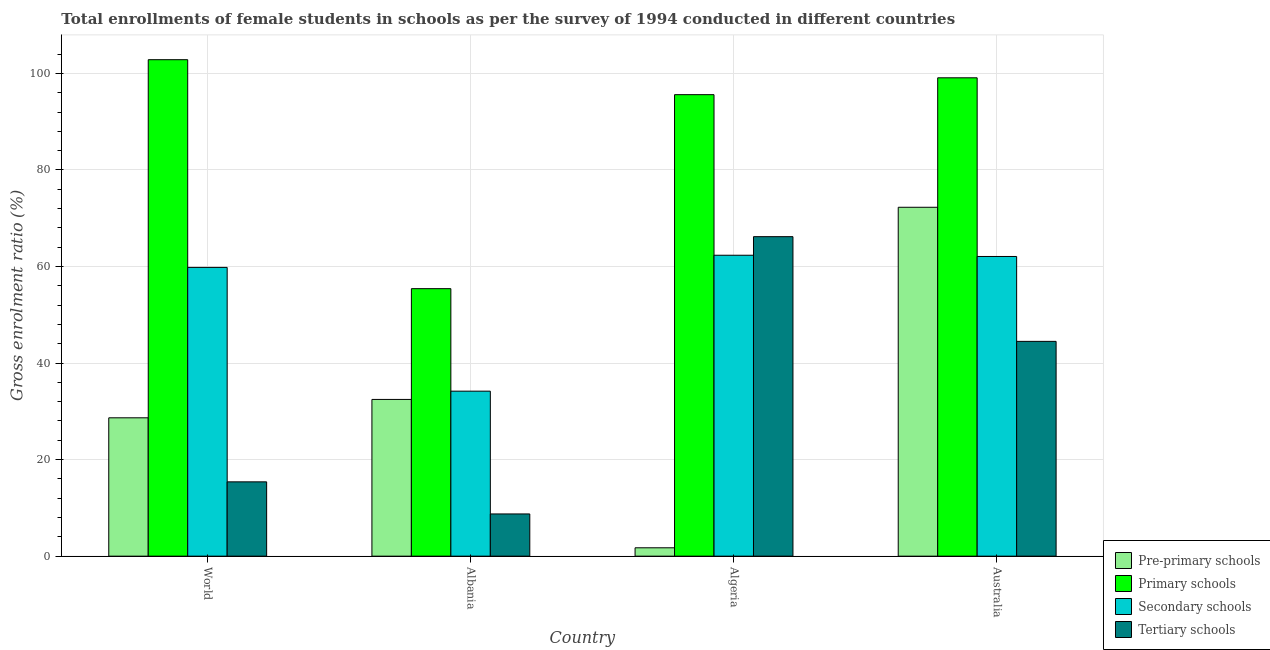How many groups of bars are there?
Provide a succinct answer. 4. Are the number of bars per tick equal to the number of legend labels?
Give a very brief answer. Yes. Are the number of bars on each tick of the X-axis equal?
Your response must be concise. Yes. How many bars are there on the 3rd tick from the left?
Ensure brevity in your answer.  4. How many bars are there on the 4th tick from the right?
Keep it short and to the point. 4. In how many cases, is the number of bars for a given country not equal to the number of legend labels?
Your answer should be compact. 0. What is the gross enrolment ratio(female) in primary schools in Australia?
Ensure brevity in your answer.  99.08. Across all countries, what is the maximum gross enrolment ratio(female) in primary schools?
Keep it short and to the point. 102.83. Across all countries, what is the minimum gross enrolment ratio(female) in tertiary schools?
Your answer should be very brief. 8.75. In which country was the gross enrolment ratio(female) in tertiary schools maximum?
Offer a terse response. Algeria. In which country was the gross enrolment ratio(female) in secondary schools minimum?
Offer a very short reply. Albania. What is the total gross enrolment ratio(female) in primary schools in the graph?
Offer a very short reply. 352.92. What is the difference between the gross enrolment ratio(female) in secondary schools in Algeria and that in Australia?
Keep it short and to the point. 0.26. What is the difference between the gross enrolment ratio(female) in secondary schools in Algeria and the gross enrolment ratio(female) in pre-primary schools in World?
Offer a terse response. 33.67. What is the average gross enrolment ratio(female) in secondary schools per country?
Provide a succinct answer. 54.6. What is the difference between the gross enrolment ratio(female) in tertiary schools and gross enrolment ratio(female) in primary schools in World?
Give a very brief answer. -87.44. In how many countries, is the gross enrolment ratio(female) in tertiary schools greater than 88 %?
Your answer should be very brief. 0. What is the ratio of the gross enrolment ratio(female) in secondary schools in Australia to that in World?
Your answer should be very brief. 1.04. Is the gross enrolment ratio(female) in tertiary schools in Albania less than that in Australia?
Ensure brevity in your answer.  Yes. What is the difference between the highest and the second highest gross enrolment ratio(female) in pre-primary schools?
Your response must be concise. 39.8. What is the difference between the highest and the lowest gross enrolment ratio(female) in secondary schools?
Provide a short and direct response. 28.15. Is the sum of the gross enrolment ratio(female) in pre-primary schools in Albania and Australia greater than the maximum gross enrolment ratio(female) in tertiary schools across all countries?
Offer a very short reply. Yes. Is it the case that in every country, the sum of the gross enrolment ratio(female) in primary schools and gross enrolment ratio(female) in pre-primary schools is greater than the sum of gross enrolment ratio(female) in secondary schools and gross enrolment ratio(female) in tertiary schools?
Give a very brief answer. No. What does the 3rd bar from the left in World represents?
Provide a short and direct response. Secondary schools. What does the 1st bar from the right in Algeria represents?
Your response must be concise. Tertiary schools. Is it the case that in every country, the sum of the gross enrolment ratio(female) in pre-primary schools and gross enrolment ratio(female) in primary schools is greater than the gross enrolment ratio(female) in secondary schools?
Provide a short and direct response. Yes. How many bars are there?
Offer a very short reply. 16. How many countries are there in the graph?
Your answer should be compact. 4. What is the difference between two consecutive major ticks on the Y-axis?
Provide a succinct answer. 20. Does the graph contain grids?
Provide a succinct answer. Yes. Where does the legend appear in the graph?
Your response must be concise. Bottom right. How are the legend labels stacked?
Make the answer very short. Vertical. What is the title of the graph?
Keep it short and to the point. Total enrollments of female students in schools as per the survey of 1994 conducted in different countries. Does "Norway" appear as one of the legend labels in the graph?
Your answer should be compact. No. What is the label or title of the Y-axis?
Your response must be concise. Gross enrolment ratio (%). What is the Gross enrolment ratio (%) of Pre-primary schools in World?
Give a very brief answer. 28.66. What is the Gross enrolment ratio (%) in Primary schools in World?
Provide a short and direct response. 102.83. What is the Gross enrolment ratio (%) of Secondary schools in World?
Offer a terse response. 59.81. What is the Gross enrolment ratio (%) in Tertiary schools in World?
Give a very brief answer. 15.39. What is the Gross enrolment ratio (%) of Pre-primary schools in Albania?
Provide a short and direct response. 32.47. What is the Gross enrolment ratio (%) in Primary schools in Albania?
Make the answer very short. 55.41. What is the Gross enrolment ratio (%) in Secondary schools in Albania?
Give a very brief answer. 34.18. What is the Gross enrolment ratio (%) in Tertiary schools in Albania?
Offer a very short reply. 8.75. What is the Gross enrolment ratio (%) in Pre-primary schools in Algeria?
Your response must be concise. 1.74. What is the Gross enrolment ratio (%) in Primary schools in Algeria?
Keep it short and to the point. 95.59. What is the Gross enrolment ratio (%) in Secondary schools in Algeria?
Offer a very short reply. 62.33. What is the Gross enrolment ratio (%) in Tertiary schools in Algeria?
Give a very brief answer. 66.18. What is the Gross enrolment ratio (%) in Pre-primary schools in Australia?
Offer a very short reply. 72.27. What is the Gross enrolment ratio (%) of Primary schools in Australia?
Make the answer very short. 99.08. What is the Gross enrolment ratio (%) of Secondary schools in Australia?
Offer a very short reply. 62.08. What is the Gross enrolment ratio (%) in Tertiary schools in Australia?
Ensure brevity in your answer.  44.49. Across all countries, what is the maximum Gross enrolment ratio (%) of Pre-primary schools?
Make the answer very short. 72.27. Across all countries, what is the maximum Gross enrolment ratio (%) in Primary schools?
Provide a short and direct response. 102.83. Across all countries, what is the maximum Gross enrolment ratio (%) of Secondary schools?
Provide a short and direct response. 62.33. Across all countries, what is the maximum Gross enrolment ratio (%) in Tertiary schools?
Provide a succinct answer. 66.18. Across all countries, what is the minimum Gross enrolment ratio (%) of Pre-primary schools?
Make the answer very short. 1.74. Across all countries, what is the minimum Gross enrolment ratio (%) in Primary schools?
Provide a succinct answer. 55.41. Across all countries, what is the minimum Gross enrolment ratio (%) in Secondary schools?
Offer a very short reply. 34.18. Across all countries, what is the minimum Gross enrolment ratio (%) in Tertiary schools?
Offer a very short reply. 8.75. What is the total Gross enrolment ratio (%) of Pre-primary schools in the graph?
Keep it short and to the point. 135.13. What is the total Gross enrolment ratio (%) of Primary schools in the graph?
Make the answer very short. 352.92. What is the total Gross enrolment ratio (%) in Secondary schools in the graph?
Your response must be concise. 218.4. What is the total Gross enrolment ratio (%) in Tertiary schools in the graph?
Ensure brevity in your answer.  134.81. What is the difference between the Gross enrolment ratio (%) of Pre-primary schools in World and that in Albania?
Offer a terse response. -3.81. What is the difference between the Gross enrolment ratio (%) in Primary schools in World and that in Albania?
Give a very brief answer. 47.42. What is the difference between the Gross enrolment ratio (%) in Secondary schools in World and that in Albania?
Offer a very short reply. 25.63. What is the difference between the Gross enrolment ratio (%) of Tertiary schools in World and that in Albania?
Offer a very short reply. 6.65. What is the difference between the Gross enrolment ratio (%) of Pre-primary schools in World and that in Algeria?
Offer a very short reply. 26.92. What is the difference between the Gross enrolment ratio (%) of Primary schools in World and that in Algeria?
Your answer should be very brief. 7.24. What is the difference between the Gross enrolment ratio (%) in Secondary schools in World and that in Algeria?
Make the answer very short. -2.52. What is the difference between the Gross enrolment ratio (%) of Tertiary schools in World and that in Algeria?
Ensure brevity in your answer.  -50.78. What is the difference between the Gross enrolment ratio (%) in Pre-primary schools in World and that in Australia?
Make the answer very short. -43.61. What is the difference between the Gross enrolment ratio (%) of Primary schools in World and that in Australia?
Keep it short and to the point. 3.75. What is the difference between the Gross enrolment ratio (%) in Secondary schools in World and that in Australia?
Give a very brief answer. -2.26. What is the difference between the Gross enrolment ratio (%) in Tertiary schools in World and that in Australia?
Give a very brief answer. -29.1. What is the difference between the Gross enrolment ratio (%) in Pre-primary schools in Albania and that in Algeria?
Keep it short and to the point. 30.73. What is the difference between the Gross enrolment ratio (%) in Primary schools in Albania and that in Algeria?
Keep it short and to the point. -40.18. What is the difference between the Gross enrolment ratio (%) in Secondary schools in Albania and that in Algeria?
Provide a short and direct response. -28.15. What is the difference between the Gross enrolment ratio (%) in Tertiary schools in Albania and that in Algeria?
Offer a terse response. -57.43. What is the difference between the Gross enrolment ratio (%) of Pre-primary schools in Albania and that in Australia?
Provide a short and direct response. -39.8. What is the difference between the Gross enrolment ratio (%) in Primary schools in Albania and that in Australia?
Offer a terse response. -43.67. What is the difference between the Gross enrolment ratio (%) in Secondary schools in Albania and that in Australia?
Make the answer very short. -27.9. What is the difference between the Gross enrolment ratio (%) of Tertiary schools in Albania and that in Australia?
Your response must be concise. -35.74. What is the difference between the Gross enrolment ratio (%) of Pre-primary schools in Algeria and that in Australia?
Provide a short and direct response. -70.53. What is the difference between the Gross enrolment ratio (%) of Primary schools in Algeria and that in Australia?
Your response must be concise. -3.49. What is the difference between the Gross enrolment ratio (%) of Secondary schools in Algeria and that in Australia?
Your answer should be very brief. 0.26. What is the difference between the Gross enrolment ratio (%) in Tertiary schools in Algeria and that in Australia?
Your answer should be very brief. 21.69. What is the difference between the Gross enrolment ratio (%) of Pre-primary schools in World and the Gross enrolment ratio (%) of Primary schools in Albania?
Your answer should be very brief. -26.75. What is the difference between the Gross enrolment ratio (%) of Pre-primary schools in World and the Gross enrolment ratio (%) of Secondary schools in Albania?
Provide a succinct answer. -5.52. What is the difference between the Gross enrolment ratio (%) in Pre-primary schools in World and the Gross enrolment ratio (%) in Tertiary schools in Albania?
Provide a succinct answer. 19.91. What is the difference between the Gross enrolment ratio (%) in Primary schools in World and the Gross enrolment ratio (%) in Secondary schools in Albania?
Give a very brief answer. 68.66. What is the difference between the Gross enrolment ratio (%) in Primary schools in World and the Gross enrolment ratio (%) in Tertiary schools in Albania?
Provide a succinct answer. 94.09. What is the difference between the Gross enrolment ratio (%) of Secondary schools in World and the Gross enrolment ratio (%) of Tertiary schools in Albania?
Offer a very short reply. 51.06. What is the difference between the Gross enrolment ratio (%) in Pre-primary schools in World and the Gross enrolment ratio (%) in Primary schools in Algeria?
Keep it short and to the point. -66.93. What is the difference between the Gross enrolment ratio (%) in Pre-primary schools in World and the Gross enrolment ratio (%) in Secondary schools in Algeria?
Provide a succinct answer. -33.67. What is the difference between the Gross enrolment ratio (%) of Pre-primary schools in World and the Gross enrolment ratio (%) of Tertiary schools in Algeria?
Keep it short and to the point. -37.52. What is the difference between the Gross enrolment ratio (%) in Primary schools in World and the Gross enrolment ratio (%) in Secondary schools in Algeria?
Make the answer very short. 40.5. What is the difference between the Gross enrolment ratio (%) of Primary schools in World and the Gross enrolment ratio (%) of Tertiary schools in Algeria?
Your answer should be very brief. 36.65. What is the difference between the Gross enrolment ratio (%) of Secondary schools in World and the Gross enrolment ratio (%) of Tertiary schools in Algeria?
Offer a very short reply. -6.37. What is the difference between the Gross enrolment ratio (%) in Pre-primary schools in World and the Gross enrolment ratio (%) in Primary schools in Australia?
Make the answer very short. -70.42. What is the difference between the Gross enrolment ratio (%) in Pre-primary schools in World and the Gross enrolment ratio (%) in Secondary schools in Australia?
Provide a short and direct response. -33.42. What is the difference between the Gross enrolment ratio (%) in Pre-primary schools in World and the Gross enrolment ratio (%) in Tertiary schools in Australia?
Offer a terse response. -15.83. What is the difference between the Gross enrolment ratio (%) in Primary schools in World and the Gross enrolment ratio (%) in Secondary schools in Australia?
Your answer should be compact. 40.76. What is the difference between the Gross enrolment ratio (%) of Primary schools in World and the Gross enrolment ratio (%) of Tertiary schools in Australia?
Make the answer very short. 58.34. What is the difference between the Gross enrolment ratio (%) in Secondary schools in World and the Gross enrolment ratio (%) in Tertiary schools in Australia?
Give a very brief answer. 15.32. What is the difference between the Gross enrolment ratio (%) in Pre-primary schools in Albania and the Gross enrolment ratio (%) in Primary schools in Algeria?
Your response must be concise. -63.13. What is the difference between the Gross enrolment ratio (%) in Pre-primary schools in Albania and the Gross enrolment ratio (%) in Secondary schools in Algeria?
Provide a short and direct response. -29.87. What is the difference between the Gross enrolment ratio (%) of Pre-primary schools in Albania and the Gross enrolment ratio (%) of Tertiary schools in Algeria?
Keep it short and to the point. -33.71. What is the difference between the Gross enrolment ratio (%) of Primary schools in Albania and the Gross enrolment ratio (%) of Secondary schools in Algeria?
Give a very brief answer. -6.92. What is the difference between the Gross enrolment ratio (%) of Primary schools in Albania and the Gross enrolment ratio (%) of Tertiary schools in Algeria?
Provide a short and direct response. -10.77. What is the difference between the Gross enrolment ratio (%) of Secondary schools in Albania and the Gross enrolment ratio (%) of Tertiary schools in Algeria?
Give a very brief answer. -32. What is the difference between the Gross enrolment ratio (%) in Pre-primary schools in Albania and the Gross enrolment ratio (%) in Primary schools in Australia?
Your response must be concise. -66.62. What is the difference between the Gross enrolment ratio (%) of Pre-primary schools in Albania and the Gross enrolment ratio (%) of Secondary schools in Australia?
Keep it short and to the point. -29.61. What is the difference between the Gross enrolment ratio (%) in Pre-primary schools in Albania and the Gross enrolment ratio (%) in Tertiary schools in Australia?
Your response must be concise. -12.03. What is the difference between the Gross enrolment ratio (%) of Primary schools in Albania and the Gross enrolment ratio (%) of Secondary schools in Australia?
Make the answer very short. -6.67. What is the difference between the Gross enrolment ratio (%) of Primary schools in Albania and the Gross enrolment ratio (%) of Tertiary schools in Australia?
Your response must be concise. 10.92. What is the difference between the Gross enrolment ratio (%) of Secondary schools in Albania and the Gross enrolment ratio (%) of Tertiary schools in Australia?
Give a very brief answer. -10.31. What is the difference between the Gross enrolment ratio (%) in Pre-primary schools in Algeria and the Gross enrolment ratio (%) in Primary schools in Australia?
Make the answer very short. -97.35. What is the difference between the Gross enrolment ratio (%) of Pre-primary schools in Algeria and the Gross enrolment ratio (%) of Secondary schools in Australia?
Your answer should be very brief. -60.34. What is the difference between the Gross enrolment ratio (%) of Pre-primary schools in Algeria and the Gross enrolment ratio (%) of Tertiary schools in Australia?
Your answer should be very brief. -42.76. What is the difference between the Gross enrolment ratio (%) in Primary schools in Algeria and the Gross enrolment ratio (%) in Secondary schools in Australia?
Offer a very short reply. 33.52. What is the difference between the Gross enrolment ratio (%) in Primary schools in Algeria and the Gross enrolment ratio (%) in Tertiary schools in Australia?
Give a very brief answer. 51.1. What is the difference between the Gross enrolment ratio (%) of Secondary schools in Algeria and the Gross enrolment ratio (%) of Tertiary schools in Australia?
Your answer should be very brief. 17.84. What is the average Gross enrolment ratio (%) of Pre-primary schools per country?
Make the answer very short. 33.78. What is the average Gross enrolment ratio (%) of Primary schools per country?
Keep it short and to the point. 88.23. What is the average Gross enrolment ratio (%) of Secondary schools per country?
Your answer should be compact. 54.6. What is the average Gross enrolment ratio (%) of Tertiary schools per country?
Ensure brevity in your answer.  33.7. What is the difference between the Gross enrolment ratio (%) in Pre-primary schools and Gross enrolment ratio (%) in Primary schools in World?
Keep it short and to the point. -74.17. What is the difference between the Gross enrolment ratio (%) in Pre-primary schools and Gross enrolment ratio (%) in Secondary schools in World?
Offer a very short reply. -31.15. What is the difference between the Gross enrolment ratio (%) of Pre-primary schools and Gross enrolment ratio (%) of Tertiary schools in World?
Offer a very short reply. 13.27. What is the difference between the Gross enrolment ratio (%) in Primary schools and Gross enrolment ratio (%) in Secondary schools in World?
Your answer should be very brief. 43.02. What is the difference between the Gross enrolment ratio (%) of Primary schools and Gross enrolment ratio (%) of Tertiary schools in World?
Provide a succinct answer. 87.44. What is the difference between the Gross enrolment ratio (%) of Secondary schools and Gross enrolment ratio (%) of Tertiary schools in World?
Your answer should be compact. 44.42. What is the difference between the Gross enrolment ratio (%) of Pre-primary schools and Gross enrolment ratio (%) of Primary schools in Albania?
Ensure brevity in your answer.  -22.94. What is the difference between the Gross enrolment ratio (%) of Pre-primary schools and Gross enrolment ratio (%) of Secondary schools in Albania?
Give a very brief answer. -1.71. What is the difference between the Gross enrolment ratio (%) of Pre-primary schools and Gross enrolment ratio (%) of Tertiary schools in Albania?
Your answer should be very brief. 23.72. What is the difference between the Gross enrolment ratio (%) in Primary schools and Gross enrolment ratio (%) in Secondary schools in Albania?
Provide a succinct answer. 21.23. What is the difference between the Gross enrolment ratio (%) in Primary schools and Gross enrolment ratio (%) in Tertiary schools in Albania?
Your response must be concise. 46.66. What is the difference between the Gross enrolment ratio (%) in Secondary schools and Gross enrolment ratio (%) in Tertiary schools in Albania?
Offer a very short reply. 25.43. What is the difference between the Gross enrolment ratio (%) in Pre-primary schools and Gross enrolment ratio (%) in Primary schools in Algeria?
Give a very brief answer. -93.86. What is the difference between the Gross enrolment ratio (%) of Pre-primary schools and Gross enrolment ratio (%) of Secondary schools in Algeria?
Your answer should be very brief. -60.6. What is the difference between the Gross enrolment ratio (%) of Pre-primary schools and Gross enrolment ratio (%) of Tertiary schools in Algeria?
Make the answer very short. -64.44. What is the difference between the Gross enrolment ratio (%) in Primary schools and Gross enrolment ratio (%) in Secondary schools in Algeria?
Offer a very short reply. 33.26. What is the difference between the Gross enrolment ratio (%) in Primary schools and Gross enrolment ratio (%) in Tertiary schools in Algeria?
Provide a succinct answer. 29.41. What is the difference between the Gross enrolment ratio (%) in Secondary schools and Gross enrolment ratio (%) in Tertiary schools in Algeria?
Your response must be concise. -3.85. What is the difference between the Gross enrolment ratio (%) in Pre-primary schools and Gross enrolment ratio (%) in Primary schools in Australia?
Offer a terse response. -26.82. What is the difference between the Gross enrolment ratio (%) of Pre-primary schools and Gross enrolment ratio (%) of Secondary schools in Australia?
Ensure brevity in your answer.  10.19. What is the difference between the Gross enrolment ratio (%) in Pre-primary schools and Gross enrolment ratio (%) in Tertiary schools in Australia?
Give a very brief answer. 27.78. What is the difference between the Gross enrolment ratio (%) in Primary schools and Gross enrolment ratio (%) in Secondary schools in Australia?
Keep it short and to the point. 37.01. What is the difference between the Gross enrolment ratio (%) in Primary schools and Gross enrolment ratio (%) in Tertiary schools in Australia?
Provide a short and direct response. 54.59. What is the difference between the Gross enrolment ratio (%) in Secondary schools and Gross enrolment ratio (%) in Tertiary schools in Australia?
Provide a short and direct response. 17.58. What is the ratio of the Gross enrolment ratio (%) of Pre-primary schools in World to that in Albania?
Your answer should be compact. 0.88. What is the ratio of the Gross enrolment ratio (%) in Primary schools in World to that in Albania?
Offer a terse response. 1.86. What is the ratio of the Gross enrolment ratio (%) in Secondary schools in World to that in Albania?
Offer a terse response. 1.75. What is the ratio of the Gross enrolment ratio (%) of Tertiary schools in World to that in Albania?
Ensure brevity in your answer.  1.76. What is the ratio of the Gross enrolment ratio (%) of Pre-primary schools in World to that in Algeria?
Provide a short and direct response. 16.52. What is the ratio of the Gross enrolment ratio (%) in Primary schools in World to that in Algeria?
Keep it short and to the point. 1.08. What is the ratio of the Gross enrolment ratio (%) in Secondary schools in World to that in Algeria?
Provide a short and direct response. 0.96. What is the ratio of the Gross enrolment ratio (%) in Tertiary schools in World to that in Algeria?
Your answer should be very brief. 0.23. What is the ratio of the Gross enrolment ratio (%) in Pre-primary schools in World to that in Australia?
Keep it short and to the point. 0.4. What is the ratio of the Gross enrolment ratio (%) in Primary schools in World to that in Australia?
Provide a succinct answer. 1.04. What is the ratio of the Gross enrolment ratio (%) of Secondary schools in World to that in Australia?
Your answer should be compact. 0.96. What is the ratio of the Gross enrolment ratio (%) in Tertiary schools in World to that in Australia?
Give a very brief answer. 0.35. What is the ratio of the Gross enrolment ratio (%) in Pre-primary schools in Albania to that in Algeria?
Provide a succinct answer. 18.71. What is the ratio of the Gross enrolment ratio (%) in Primary schools in Albania to that in Algeria?
Provide a succinct answer. 0.58. What is the ratio of the Gross enrolment ratio (%) in Secondary schools in Albania to that in Algeria?
Offer a very short reply. 0.55. What is the ratio of the Gross enrolment ratio (%) of Tertiary schools in Albania to that in Algeria?
Ensure brevity in your answer.  0.13. What is the ratio of the Gross enrolment ratio (%) of Pre-primary schools in Albania to that in Australia?
Your answer should be very brief. 0.45. What is the ratio of the Gross enrolment ratio (%) of Primary schools in Albania to that in Australia?
Your response must be concise. 0.56. What is the ratio of the Gross enrolment ratio (%) in Secondary schools in Albania to that in Australia?
Keep it short and to the point. 0.55. What is the ratio of the Gross enrolment ratio (%) of Tertiary schools in Albania to that in Australia?
Your answer should be compact. 0.2. What is the ratio of the Gross enrolment ratio (%) of Pre-primary schools in Algeria to that in Australia?
Give a very brief answer. 0.02. What is the ratio of the Gross enrolment ratio (%) in Primary schools in Algeria to that in Australia?
Give a very brief answer. 0.96. What is the ratio of the Gross enrolment ratio (%) in Tertiary schools in Algeria to that in Australia?
Your answer should be compact. 1.49. What is the difference between the highest and the second highest Gross enrolment ratio (%) of Pre-primary schools?
Provide a short and direct response. 39.8. What is the difference between the highest and the second highest Gross enrolment ratio (%) of Primary schools?
Keep it short and to the point. 3.75. What is the difference between the highest and the second highest Gross enrolment ratio (%) of Secondary schools?
Provide a short and direct response. 0.26. What is the difference between the highest and the second highest Gross enrolment ratio (%) in Tertiary schools?
Keep it short and to the point. 21.69. What is the difference between the highest and the lowest Gross enrolment ratio (%) of Pre-primary schools?
Provide a succinct answer. 70.53. What is the difference between the highest and the lowest Gross enrolment ratio (%) of Primary schools?
Your answer should be compact. 47.42. What is the difference between the highest and the lowest Gross enrolment ratio (%) of Secondary schools?
Offer a very short reply. 28.15. What is the difference between the highest and the lowest Gross enrolment ratio (%) of Tertiary schools?
Make the answer very short. 57.43. 